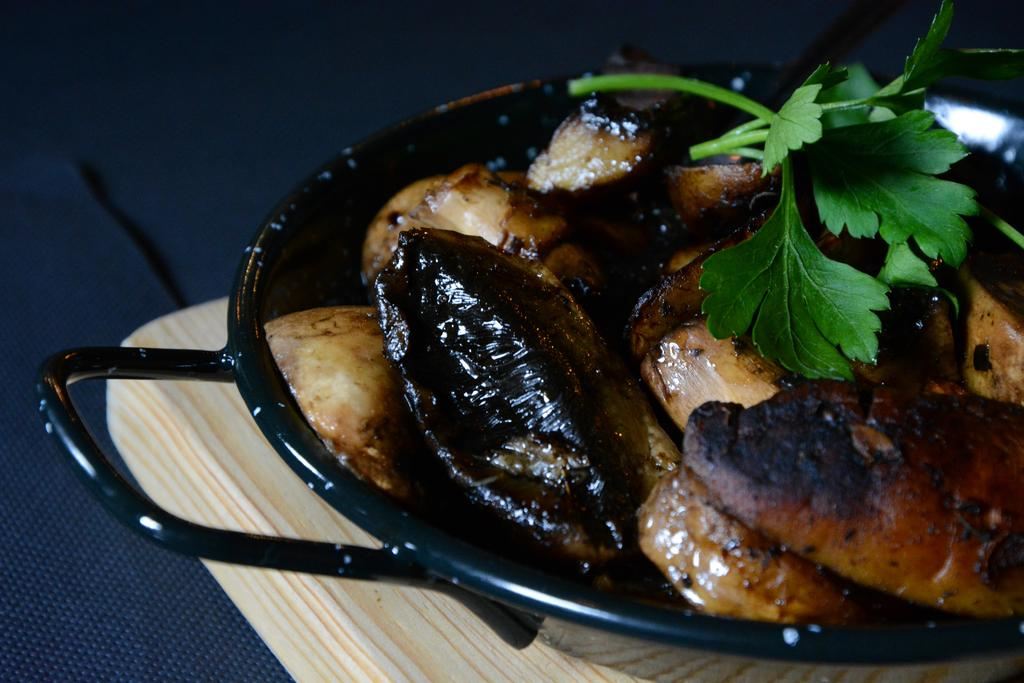What is in the utensil that is visible in the image? There is food in a utensil in the image. On what surface is the utensil placed? The utensil is placed on a wooden surface. What can be seen on the left side of the image? There is an object on the left side of the image. What type of approval does the goat in the image have? There is no goat present in the image, so it is not possible to determine any approval it might have. 